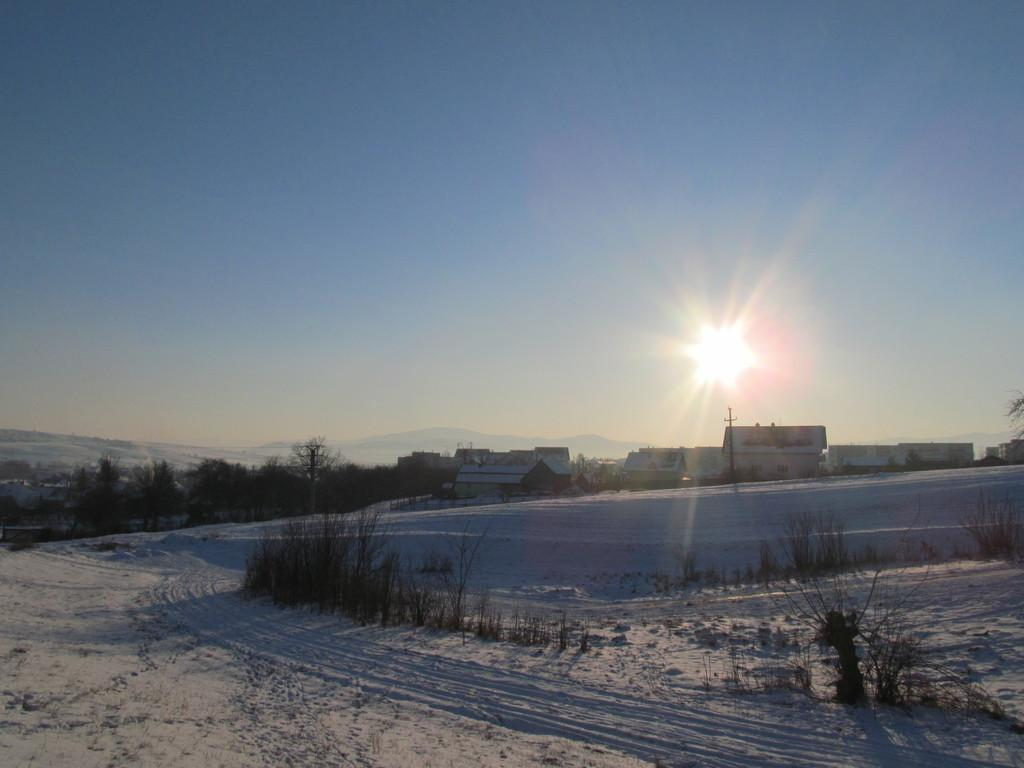What type of structures can be seen in the image? There are houses in the image. What object is present in the image that might be used for support or signage? There is a pole in the image. What type of vegetation is visible in the image? There are plants and trees in the image. What celestial body can be seen in the image? The sun is visible in the image. What is the weather like in the image? The presence of snow suggests that it is cold and possibly winter in the image. What part of the natural environment is visible in the image? The sky is visible in the image. What type of committee is meeting in the image? There is no committee meeting in the image; it features houses, a pole, plants, trees, the sun, snow, and the sky. What type of learning is taking place in the image? There is no learning taking place in the image; it is a scene of houses, a pole, plants, trees, the sun, snow, and the sky. 